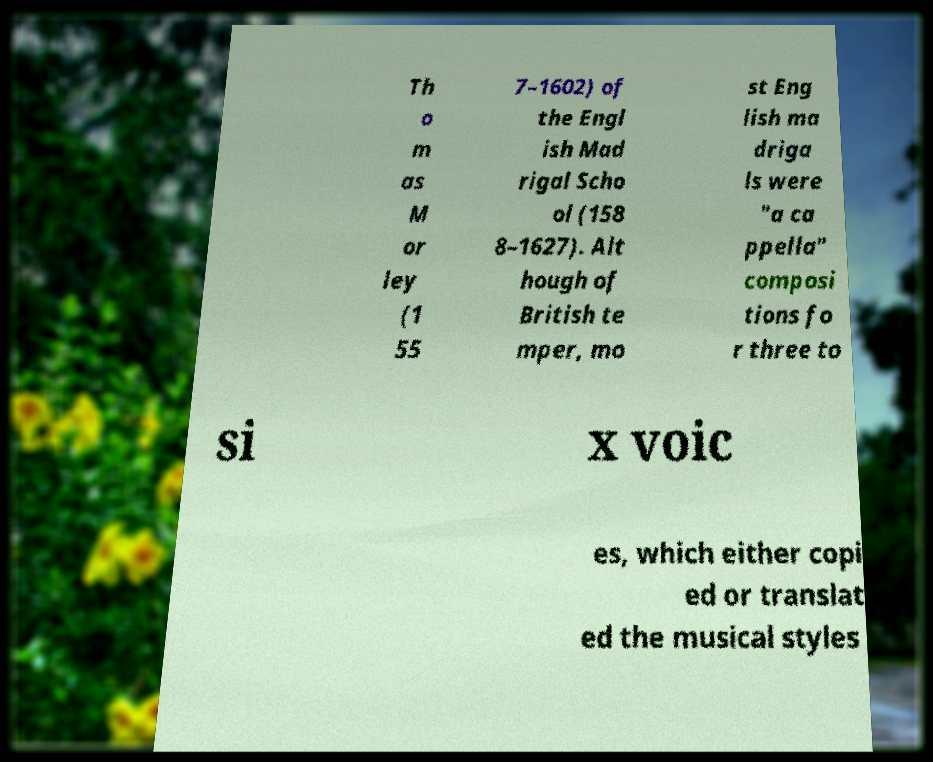There's text embedded in this image that I need extracted. Can you transcribe it verbatim? Th o m as M or ley (1 55 7–1602) of the Engl ish Mad rigal Scho ol (158 8–1627). Alt hough of British te mper, mo st Eng lish ma driga ls were "a ca ppella" composi tions fo r three to si x voic es, which either copi ed or translat ed the musical styles 